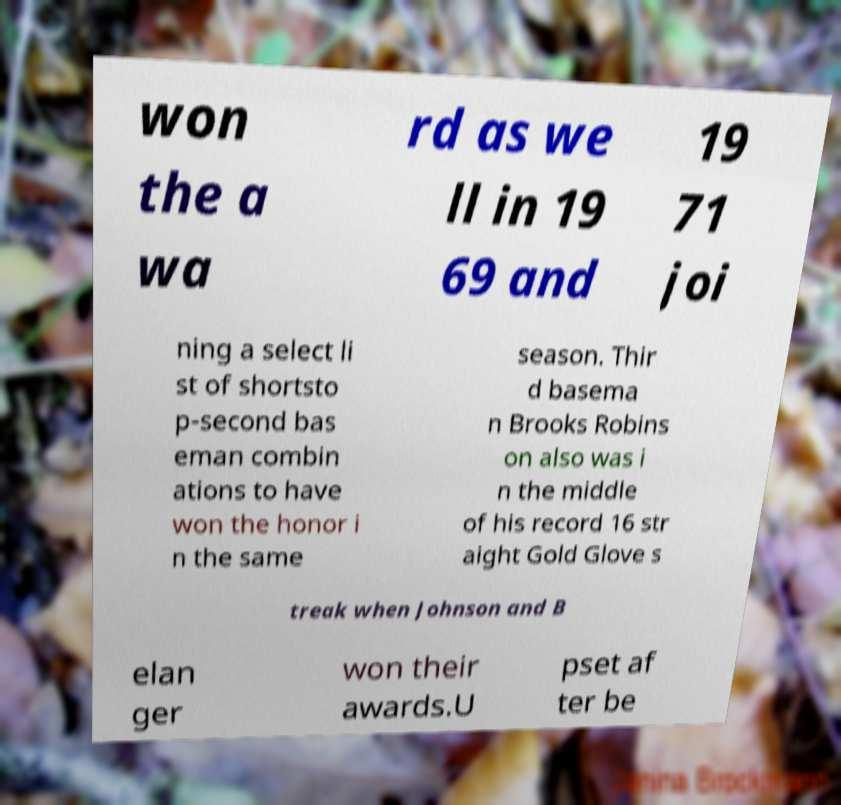Could you extract and type out the text from this image? won the a wa rd as we ll in 19 69 and 19 71 joi ning a select li st of shortsto p-second bas eman combin ations to have won the honor i n the same season. Thir d basema n Brooks Robins on also was i n the middle of his record 16 str aight Gold Glove s treak when Johnson and B elan ger won their awards.U pset af ter be 